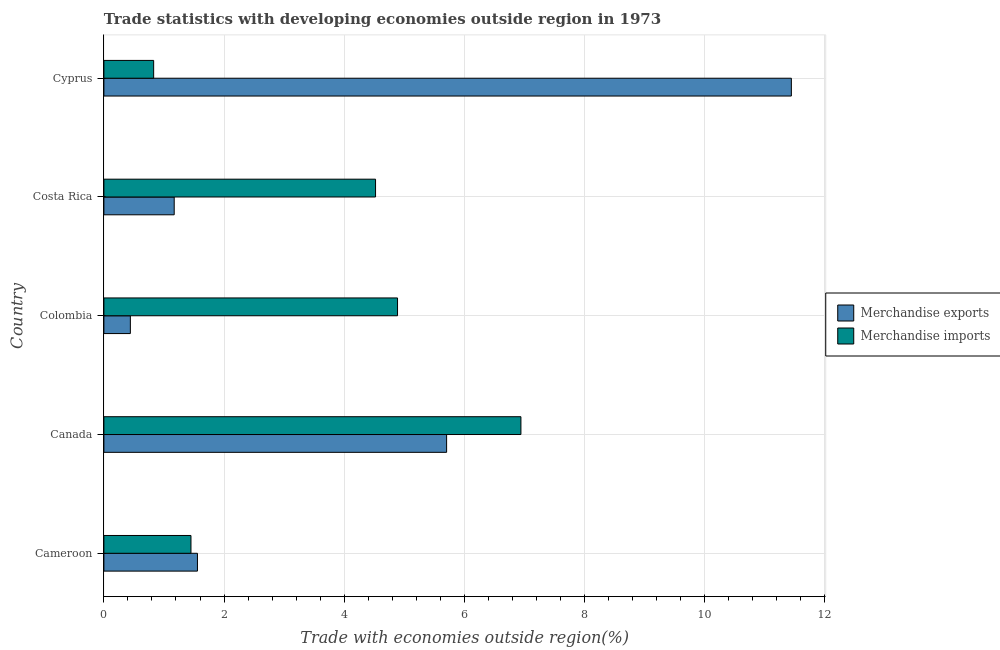How many groups of bars are there?
Offer a very short reply. 5. Are the number of bars on each tick of the Y-axis equal?
Offer a very short reply. Yes. What is the label of the 4th group of bars from the top?
Offer a very short reply. Canada. In how many cases, is the number of bars for a given country not equal to the number of legend labels?
Provide a short and direct response. 0. What is the merchandise imports in Canada?
Provide a short and direct response. 6.94. Across all countries, what is the maximum merchandise exports?
Provide a succinct answer. 11.44. Across all countries, what is the minimum merchandise exports?
Your response must be concise. 0.44. In which country was the merchandise imports maximum?
Ensure brevity in your answer.  Canada. In which country was the merchandise imports minimum?
Offer a very short reply. Cyprus. What is the total merchandise exports in the graph?
Make the answer very short. 20.32. What is the difference between the merchandise exports in Canada and that in Costa Rica?
Provide a succinct answer. 4.53. What is the difference between the merchandise exports in Costa Rica and the merchandise imports in Canada?
Keep it short and to the point. -5.77. What is the average merchandise exports per country?
Your answer should be very brief. 4.06. What is the difference between the merchandise imports and merchandise exports in Cyprus?
Provide a short and direct response. -10.61. What is the ratio of the merchandise exports in Cameroon to that in Costa Rica?
Keep it short and to the point. 1.33. Is the merchandise exports in Cameroon less than that in Costa Rica?
Provide a short and direct response. No. Is the difference between the merchandise imports in Cameroon and Colombia greater than the difference between the merchandise exports in Cameroon and Colombia?
Your response must be concise. No. What is the difference between the highest and the second highest merchandise exports?
Give a very brief answer. 5.74. What is the difference between the highest and the lowest merchandise exports?
Your answer should be very brief. 11. Is the sum of the merchandise imports in Cameroon and Costa Rica greater than the maximum merchandise exports across all countries?
Make the answer very short. No. What does the 1st bar from the bottom in Cyprus represents?
Provide a short and direct response. Merchandise exports. Are all the bars in the graph horizontal?
Provide a succinct answer. Yes. How many countries are there in the graph?
Make the answer very short. 5. What is the difference between two consecutive major ticks on the X-axis?
Your answer should be very brief. 2. Are the values on the major ticks of X-axis written in scientific E-notation?
Ensure brevity in your answer.  No. Where does the legend appear in the graph?
Offer a terse response. Center right. How many legend labels are there?
Offer a terse response. 2. How are the legend labels stacked?
Offer a terse response. Vertical. What is the title of the graph?
Ensure brevity in your answer.  Trade statistics with developing economies outside region in 1973. What is the label or title of the X-axis?
Offer a terse response. Trade with economies outside region(%). What is the label or title of the Y-axis?
Your answer should be compact. Country. What is the Trade with economies outside region(%) in Merchandise exports in Cameroon?
Offer a terse response. 1.56. What is the Trade with economies outside region(%) of Merchandise imports in Cameroon?
Your answer should be very brief. 1.45. What is the Trade with economies outside region(%) of Merchandise exports in Canada?
Keep it short and to the point. 5.7. What is the Trade with economies outside region(%) in Merchandise imports in Canada?
Your answer should be very brief. 6.94. What is the Trade with economies outside region(%) in Merchandise exports in Colombia?
Your answer should be compact. 0.44. What is the Trade with economies outside region(%) in Merchandise imports in Colombia?
Keep it short and to the point. 4.89. What is the Trade with economies outside region(%) in Merchandise exports in Costa Rica?
Provide a short and direct response. 1.17. What is the Trade with economies outside region(%) in Merchandise imports in Costa Rica?
Your answer should be very brief. 4.52. What is the Trade with economies outside region(%) in Merchandise exports in Cyprus?
Offer a very short reply. 11.44. What is the Trade with economies outside region(%) of Merchandise imports in Cyprus?
Offer a very short reply. 0.83. Across all countries, what is the maximum Trade with economies outside region(%) of Merchandise exports?
Your answer should be very brief. 11.44. Across all countries, what is the maximum Trade with economies outside region(%) in Merchandise imports?
Ensure brevity in your answer.  6.94. Across all countries, what is the minimum Trade with economies outside region(%) in Merchandise exports?
Offer a very short reply. 0.44. Across all countries, what is the minimum Trade with economies outside region(%) of Merchandise imports?
Offer a terse response. 0.83. What is the total Trade with economies outside region(%) of Merchandise exports in the graph?
Your answer should be very brief. 20.32. What is the total Trade with economies outside region(%) in Merchandise imports in the graph?
Your answer should be very brief. 18.63. What is the difference between the Trade with economies outside region(%) of Merchandise exports in Cameroon and that in Canada?
Make the answer very short. -4.15. What is the difference between the Trade with economies outside region(%) in Merchandise imports in Cameroon and that in Canada?
Offer a very short reply. -5.49. What is the difference between the Trade with economies outside region(%) of Merchandise exports in Cameroon and that in Colombia?
Offer a very short reply. 1.12. What is the difference between the Trade with economies outside region(%) in Merchandise imports in Cameroon and that in Colombia?
Your response must be concise. -3.44. What is the difference between the Trade with economies outside region(%) in Merchandise exports in Cameroon and that in Costa Rica?
Give a very brief answer. 0.39. What is the difference between the Trade with economies outside region(%) of Merchandise imports in Cameroon and that in Costa Rica?
Give a very brief answer. -3.07. What is the difference between the Trade with economies outside region(%) of Merchandise exports in Cameroon and that in Cyprus?
Keep it short and to the point. -9.89. What is the difference between the Trade with economies outside region(%) of Merchandise imports in Cameroon and that in Cyprus?
Give a very brief answer. 0.62. What is the difference between the Trade with economies outside region(%) of Merchandise exports in Canada and that in Colombia?
Offer a very short reply. 5.26. What is the difference between the Trade with economies outside region(%) of Merchandise imports in Canada and that in Colombia?
Provide a succinct answer. 2.05. What is the difference between the Trade with economies outside region(%) in Merchandise exports in Canada and that in Costa Rica?
Offer a terse response. 4.53. What is the difference between the Trade with economies outside region(%) in Merchandise imports in Canada and that in Costa Rica?
Offer a very short reply. 2.42. What is the difference between the Trade with economies outside region(%) of Merchandise exports in Canada and that in Cyprus?
Give a very brief answer. -5.74. What is the difference between the Trade with economies outside region(%) of Merchandise imports in Canada and that in Cyprus?
Ensure brevity in your answer.  6.11. What is the difference between the Trade with economies outside region(%) in Merchandise exports in Colombia and that in Costa Rica?
Provide a short and direct response. -0.73. What is the difference between the Trade with economies outside region(%) of Merchandise imports in Colombia and that in Costa Rica?
Give a very brief answer. 0.37. What is the difference between the Trade with economies outside region(%) of Merchandise exports in Colombia and that in Cyprus?
Offer a very short reply. -11. What is the difference between the Trade with economies outside region(%) in Merchandise imports in Colombia and that in Cyprus?
Provide a short and direct response. 4.06. What is the difference between the Trade with economies outside region(%) in Merchandise exports in Costa Rica and that in Cyprus?
Your answer should be very brief. -10.27. What is the difference between the Trade with economies outside region(%) in Merchandise imports in Costa Rica and that in Cyprus?
Ensure brevity in your answer.  3.69. What is the difference between the Trade with economies outside region(%) of Merchandise exports in Cameroon and the Trade with economies outside region(%) of Merchandise imports in Canada?
Provide a short and direct response. -5.38. What is the difference between the Trade with economies outside region(%) of Merchandise exports in Cameroon and the Trade with economies outside region(%) of Merchandise imports in Colombia?
Keep it short and to the point. -3.33. What is the difference between the Trade with economies outside region(%) of Merchandise exports in Cameroon and the Trade with economies outside region(%) of Merchandise imports in Costa Rica?
Make the answer very short. -2.96. What is the difference between the Trade with economies outside region(%) of Merchandise exports in Cameroon and the Trade with economies outside region(%) of Merchandise imports in Cyprus?
Your answer should be compact. 0.73. What is the difference between the Trade with economies outside region(%) of Merchandise exports in Canada and the Trade with economies outside region(%) of Merchandise imports in Colombia?
Offer a terse response. 0.82. What is the difference between the Trade with economies outside region(%) in Merchandise exports in Canada and the Trade with economies outside region(%) in Merchandise imports in Costa Rica?
Make the answer very short. 1.18. What is the difference between the Trade with economies outside region(%) in Merchandise exports in Canada and the Trade with economies outside region(%) in Merchandise imports in Cyprus?
Give a very brief answer. 4.88. What is the difference between the Trade with economies outside region(%) of Merchandise exports in Colombia and the Trade with economies outside region(%) of Merchandise imports in Costa Rica?
Your response must be concise. -4.08. What is the difference between the Trade with economies outside region(%) of Merchandise exports in Colombia and the Trade with economies outside region(%) of Merchandise imports in Cyprus?
Ensure brevity in your answer.  -0.39. What is the difference between the Trade with economies outside region(%) of Merchandise exports in Costa Rica and the Trade with economies outside region(%) of Merchandise imports in Cyprus?
Keep it short and to the point. 0.34. What is the average Trade with economies outside region(%) in Merchandise exports per country?
Your answer should be very brief. 4.06. What is the average Trade with economies outside region(%) of Merchandise imports per country?
Your answer should be very brief. 3.73. What is the difference between the Trade with economies outside region(%) of Merchandise exports and Trade with economies outside region(%) of Merchandise imports in Cameroon?
Offer a terse response. 0.11. What is the difference between the Trade with economies outside region(%) of Merchandise exports and Trade with economies outside region(%) of Merchandise imports in Canada?
Your answer should be very brief. -1.24. What is the difference between the Trade with economies outside region(%) in Merchandise exports and Trade with economies outside region(%) in Merchandise imports in Colombia?
Ensure brevity in your answer.  -4.45. What is the difference between the Trade with economies outside region(%) of Merchandise exports and Trade with economies outside region(%) of Merchandise imports in Costa Rica?
Ensure brevity in your answer.  -3.35. What is the difference between the Trade with economies outside region(%) of Merchandise exports and Trade with economies outside region(%) of Merchandise imports in Cyprus?
Give a very brief answer. 10.61. What is the ratio of the Trade with economies outside region(%) of Merchandise exports in Cameroon to that in Canada?
Provide a succinct answer. 0.27. What is the ratio of the Trade with economies outside region(%) of Merchandise imports in Cameroon to that in Canada?
Your answer should be compact. 0.21. What is the ratio of the Trade with economies outside region(%) of Merchandise exports in Cameroon to that in Colombia?
Make the answer very short. 3.53. What is the ratio of the Trade with economies outside region(%) in Merchandise imports in Cameroon to that in Colombia?
Ensure brevity in your answer.  0.3. What is the ratio of the Trade with economies outside region(%) in Merchandise exports in Cameroon to that in Costa Rica?
Provide a succinct answer. 1.33. What is the ratio of the Trade with economies outside region(%) of Merchandise imports in Cameroon to that in Costa Rica?
Your answer should be compact. 0.32. What is the ratio of the Trade with economies outside region(%) in Merchandise exports in Cameroon to that in Cyprus?
Provide a short and direct response. 0.14. What is the ratio of the Trade with economies outside region(%) of Merchandise imports in Cameroon to that in Cyprus?
Offer a terse response. 1.75. What is the ratio of the Trade with economies outside region(%) of Merchandise exports in Canada to that in Colombia?
Provide a succinct answer. 12.95. What is the ratio of the Trade with economies outside region(%) in Merchandise imports in Canada to that in Colombia?
Ensure brevity in your answer.  1.42. What is the ratio of the Trade with economies outside region(%) in Merchandise exports in Canada to that in Costa Rica?
Keep it short and to the point. 4.87. What is the ratio of the Trade with economies outside region(%) of Merchandise imports in Canada to that in Costa Rica?
Offer a very short reply. 1.54. What is the ratio of the Trade with economies outside region(%) of Merchandise exports in Canada to that in Cyprus?
Offer a very short reply. 0.5. What is the ratio of the Trade with economies outside region(%) in Merchandise imports in Canada to that in Cyprus?
Your answer should be very brief. 8.38. What is the ratio of the Trade with economies outside region(%) in Merchandise exports in Colombia to that in Costa Rica?
Offer a terse response. 0.38. What is the ratio of the Trade with economies outside region(%) of Merchandise imports in Colombia to that in Costa Rica?
Offer a terse response. 1.08. What is the ratio of the Trade with economies outside region(%) in Merchandise exports in Colombia to that in Cyprus?
Ensure brevity in your answer.  0.04. What is the ratio of the Trade with economies outside region(%) in Merchandise imports in Colombia to that in Cyprus?
Keep it short and to the point. 5.9. What is the ratio of the Trade with economies outside region(%) in Merchandise exports in Costa Rica to that in Cyprus?
Keep it short and to the point. 0.1. What is the ratio of the Trade with economies outside region(%) in Merchandise imports in Costa Rica to that in Cyprus?
Give a very brief answer. 5.46. What is the difference between the highest and the second highest Trade with economies outside region(%) of Merchandise exports?
Keep it short and to the point. 5.74. What is the difference between the highest and the second highest Trade with economies outside region(%) of Merchandise imports?
Your answer should be very brief. 2.05. What is the difference between the highest and the lowest Trade with economies outside region(%) in Merchandise exports?
Your response must be concise. 11. What is the difference between the highest and the lowest Trade with economies outside region(%) of Merchandise imports?
Your response must be concise. 6.11. 